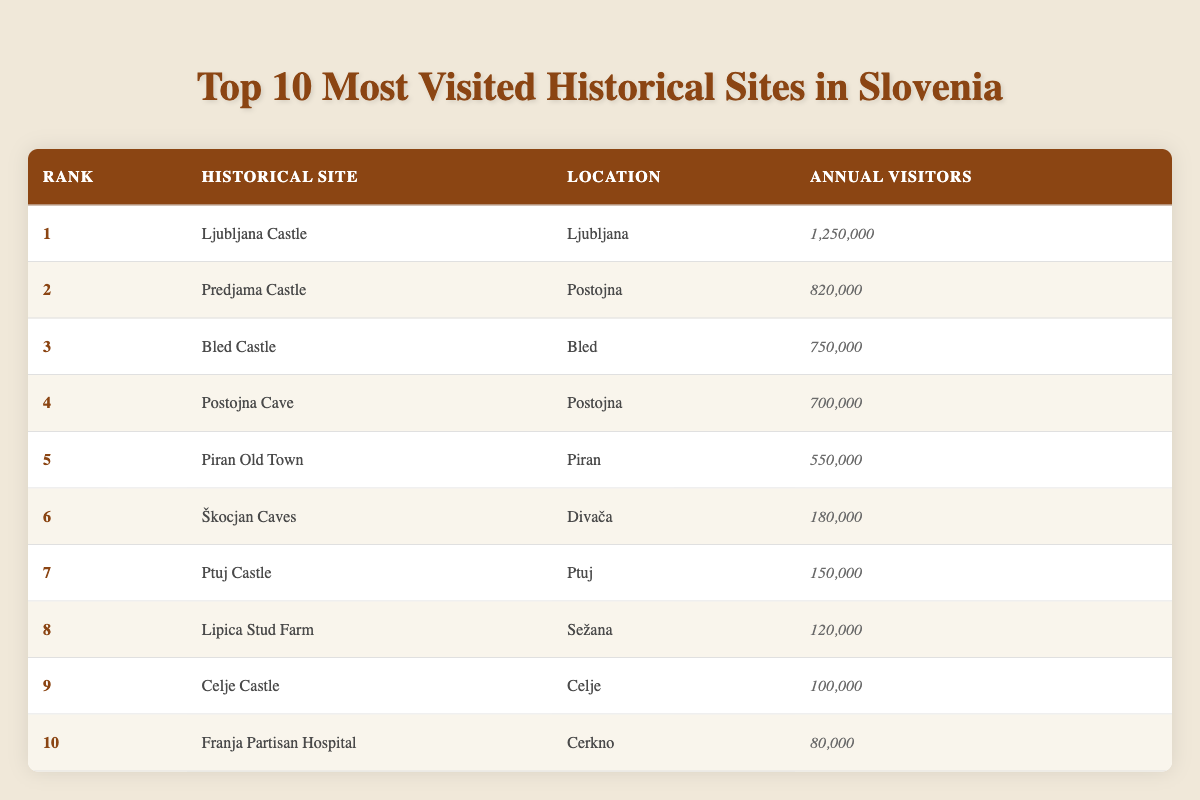What is the historical site with the highest number of annual visitors? According to the table, Ljubljana Castle is listed first with 1,250,000 annual visitors, which is the highest compared to other sites.
Answer: Ljubljana Castle How many annual visitors does Predjama Castle receive? The table shows that Predjama Castle has 820,000 annual visitors listed under the "Annual Visitors" column.
Answer: 820,000 Which historical site is located in Piran? The table indicates that Piran Old Town is the historical site located in Piran.
Answer: Piran Old Town What is the total number of annual visitors for the top three historical sites? We sum up the annual visitors for the top three sites: 1,250,000 (Ljubljana Castle) + 820,000 (Predjama Castle) + 750,000 (Bled Castle) = 2,820,000.
Answer: 2,820,000 Is Celje Castle among the top five most visited historical sites? The table lists Celje Castle in the ninth position; therefore, it is not among the top five sites.
Answer: No How many more annual visitors does Postojna Cave have compared to Lipica Stud Farm? Postojna Cave has 700,000 visitors, and Lipica Stud Farm has 120,000. The difference is 700,000 - 120,000 = 580,000.
Answer: 580,000 What percentage of the total annual visitors do the top two sites represent? The top two sites have 1,250,000 + 820,000 = 2,070,000 visitors. The total for all sites is 1,250,000 + 820,000 + 750,000 + 700,000 + 550,000 + 180,000 + 150,000 + 120,000 + 100,000 + 80,000 = 4,700,000. The percentage is (2,070,000 / 4,700,000) * 100 ≈ 44%.
Answer: Approximately 44% Which site has the least number of annual visitors and what is that number? The last entry in the table lists Franja Partisan Hospital with 80,000 annual visitors, making it the least visited site.
Answer: 80,000 How does the number of annual visitors of Škocjan Caves compare to that of Ptuj Castle? The table shows that Škocjan Caves have 180,000 visitors while Ptuj Castle has 150,000. Therefore, Škocjan Caves have 30,000 more visitors than Ptuj Castle.
Answer: Škocjan Caves have 30,000 more visitors 